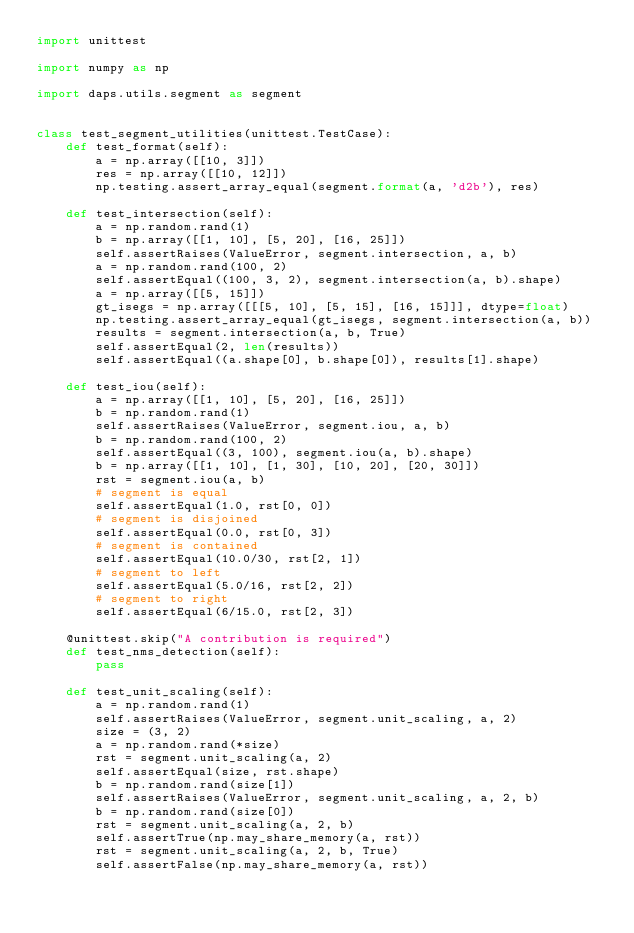<code> <loc_0><loc_0><loc_500><loc_500><_Python_>import unittest

import numpy as np

import daps.utils.segment as segment


class test_segment_utilities(unittest.TestCase):
    def test_format(self):
        a = np.array([[10, 3]])
        res = np.array([[10, 12]])
        np.testing.assert_array_equal(segment.format(a, 'd2b'), res)

    def test_intersection(self):
        a = np.random.rand(1)
        b = np.array([[1, 10], [5, 20], [16, 25]])
        self.assertRaises(ValueError, segment.intersection, a, b)
        a = np.random.rand(100, 2)
        self.assertEqual((100, 3, 2), segment.intersection(a, b).shape)
        a = np.array([[5, 15]])
        gt_isegs = np.array([[[5, 10], [5, 15], [16, 15]]], dtype=float)
        np.testing.assert_array_equal(gt_isegs, segment.intersection(a, b))
        results = segment.intersection(a, b, True)
        self.assertEqual(2, len(results))
        self.assertEqual((a.shape[0], b.shape[0]), results[1].shape)

    def test_iou(self):
        a = np.array([[1, 10], [5, 20], [16, 25]])
        b = np.random.rand(1)
        self.assertRaises(ValueError, segment.iou, a, b)
        b = np.random.rand(100, 2)
        self.assertEqual((3, 100), segment.iou(a, b).shape)
        b = np.array([[1, 10], [1, 30], [10, 20], [20, 30]])
        rst = segment.iou(a, b)
        # segment is equal
        self.assertEqual(1.0, rst[0, 0])
        # segment is disjoined
        self.assertEqual(0.0, rst[0, 3])
        # segment is contained
        self.assertEqual(10.0/30, rst[2, 1])
        # segment to left
        self.assertEqual(5.0/16, rst[2, 2])
        # segment to right
        self.assertEqual(6/15.0, rst[2, 3])

    @unittest.skip("A contribution is required")
    def test_nms_detection(self):
        pass

    def test_unit_scaling(self):
        a = np.random.rand(1)
        self.assertRaises(ValueError, segment.unit_scaling, a, 2)
        size = (3, 2)
        a = np.random.rand(*size)
        rst = segment.unit_scaling(a, 2)
        self.assertEqual(size, rst.shape)
        b = np.random.rand(size[1])
        self.assertRaises(ValueError, segment.unit_scaling, a, 2, b)
        b = np.random.rand(size[0])
        rst = segment.unit_scaling(a, 2, b)
        self.assertTrue(np.may_share_memory(a, rst))
        rst = segment.unit_scaling(a, 2, b, True)
        self.assertFalse(np.may_share_memory(a, rst))
</code> 